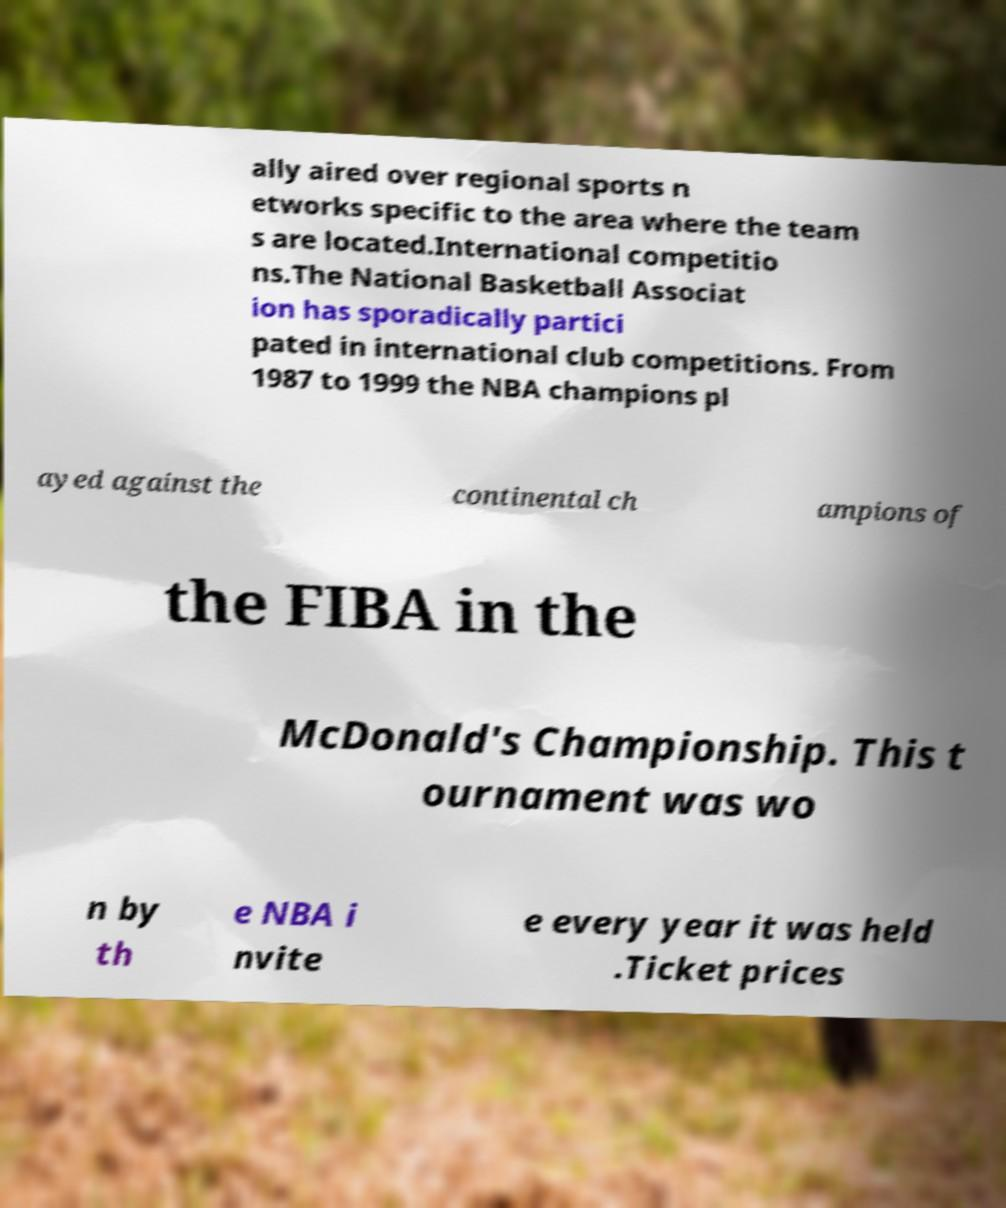What messages or text are displayed in this image? I need them in a readable, typed format. ally aired over regional sports n etworks specific to the area where the team s are located.International competitio ns.The National Basketball Associat ion has sporadically partici pated in international club competitions. From 1987 to 1999 the NBA champions pl ayed against the continental ch ampions of the FIBA in the McDonald's Championship. This t ournament was wo n by th e NBA i nvite e every year it was held .Ticket prices 